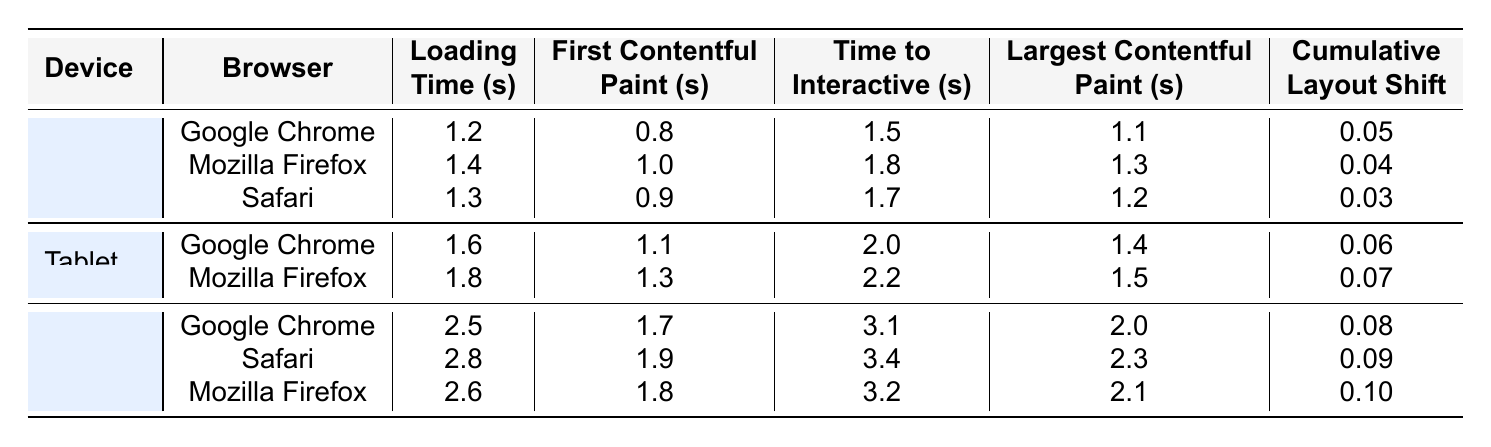What is the loading time for Mobile on Safari? Looking under the Mobile section and finding the Safari row, the loading time listed is 2.8 seconds.
Answer: 2.8 seconds Which device has the fastest First Contentful Paint across all browsers? By comparing the First Contentful Paint values for all devices and browsers, the fastest is 0.8 seconds for Google Chrome on Desktop.
Answer: 0.8 seconds What is the cumulative layout shift for Mozilla Firefox on Mobile? In the Mobile section, under Mozilla Firefox, the cumulative layout shift is listed as 0.1.
Answer: 0.1 How much longer does it take to load the page on Mobile with Google Chrome compared to Desktop with Google Chrome? The loading time for Mobile with Google Chrome is 2.5 seconds, and for Desktop with Google Chrome, it is 1.2 seconds. The difference is 2.5 - 1.2 = 1.3 seconds.
Answer: 1.3 seconds What is the average time to interactive for Tablet across both browsers? The time to interactive for Google Chrome on Tablet is 2.0 seconds and for Mozilla Firefox is 2.2 seconds. The average is (2.0 + 2.2) / 2 = 2.1 seconds.
Answer: 2.1 seconds Is the loading time for Mozilla Firefox on Desktop less than that on Tablet for the same browser? The loading time for Mozilla Firefox on Desktop is 1.4 seconds, and for Tablet, it is 1.8 seconds. Since 1.4 is less than 1.8, the answer is yes.
Answer: Yes Which device and browser combination has the highest loading time? Comparing all loading times in the table, Mobile with Safari has the highest loading time at 2.8 seconds.
Answer: Mobile with Safari What is the difference in Largest Contentful Paint between Desktop on Google Chrome and Tablet on Google Chrome? For Google Chrome, the Largest Contentful Paint for Desktop is 1.1 seconds, and for Tablet, it is 1.4 seconds. The difference is 1.4 - 1.1 = 0.3 seconds.
Answer: 0.3 seconds What browser shows the best performance (lowest loading time) on Desktop? Among the three browsers, Google Chrome has the lowest loading time on Desktop at 1.2 seconds compared to 1.4 seconds for Mozilla Firefox and 1.3 seconds for Safari.
Answer: Google Chrome Is the cumulative layout shift on Tablet for Google Chrome greater than that for Mozilla Firefox? The cumulative layout shift for Google Chrome on Tablet is 0.06 and for Mozilla Firefox is 0.07. Since 0.06 is not greater than 0.07, the answer is no.
Answer: No 